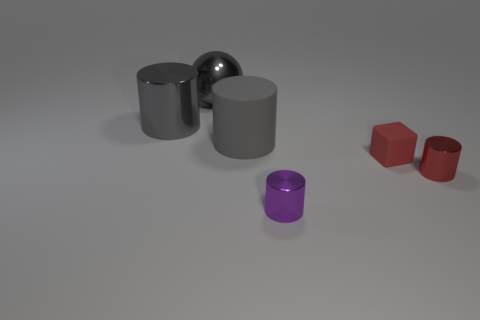The metal object that is in front of the tiny thing on the right side of the matte thing that is to the right of the gray rubber object is what shape? cylinder 